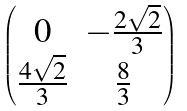Convert formula to latex. <formula><loc_0><loc_0><loc_500><loc_500>\begin{pmatrix} 0 & - \frac { 2 \sqrt { 2 } } { 3 } \\ \frac { 4 \sqrt { 2 } } 3 & \frac { 8 } { 3 } \end{pmatrix}</formula> 